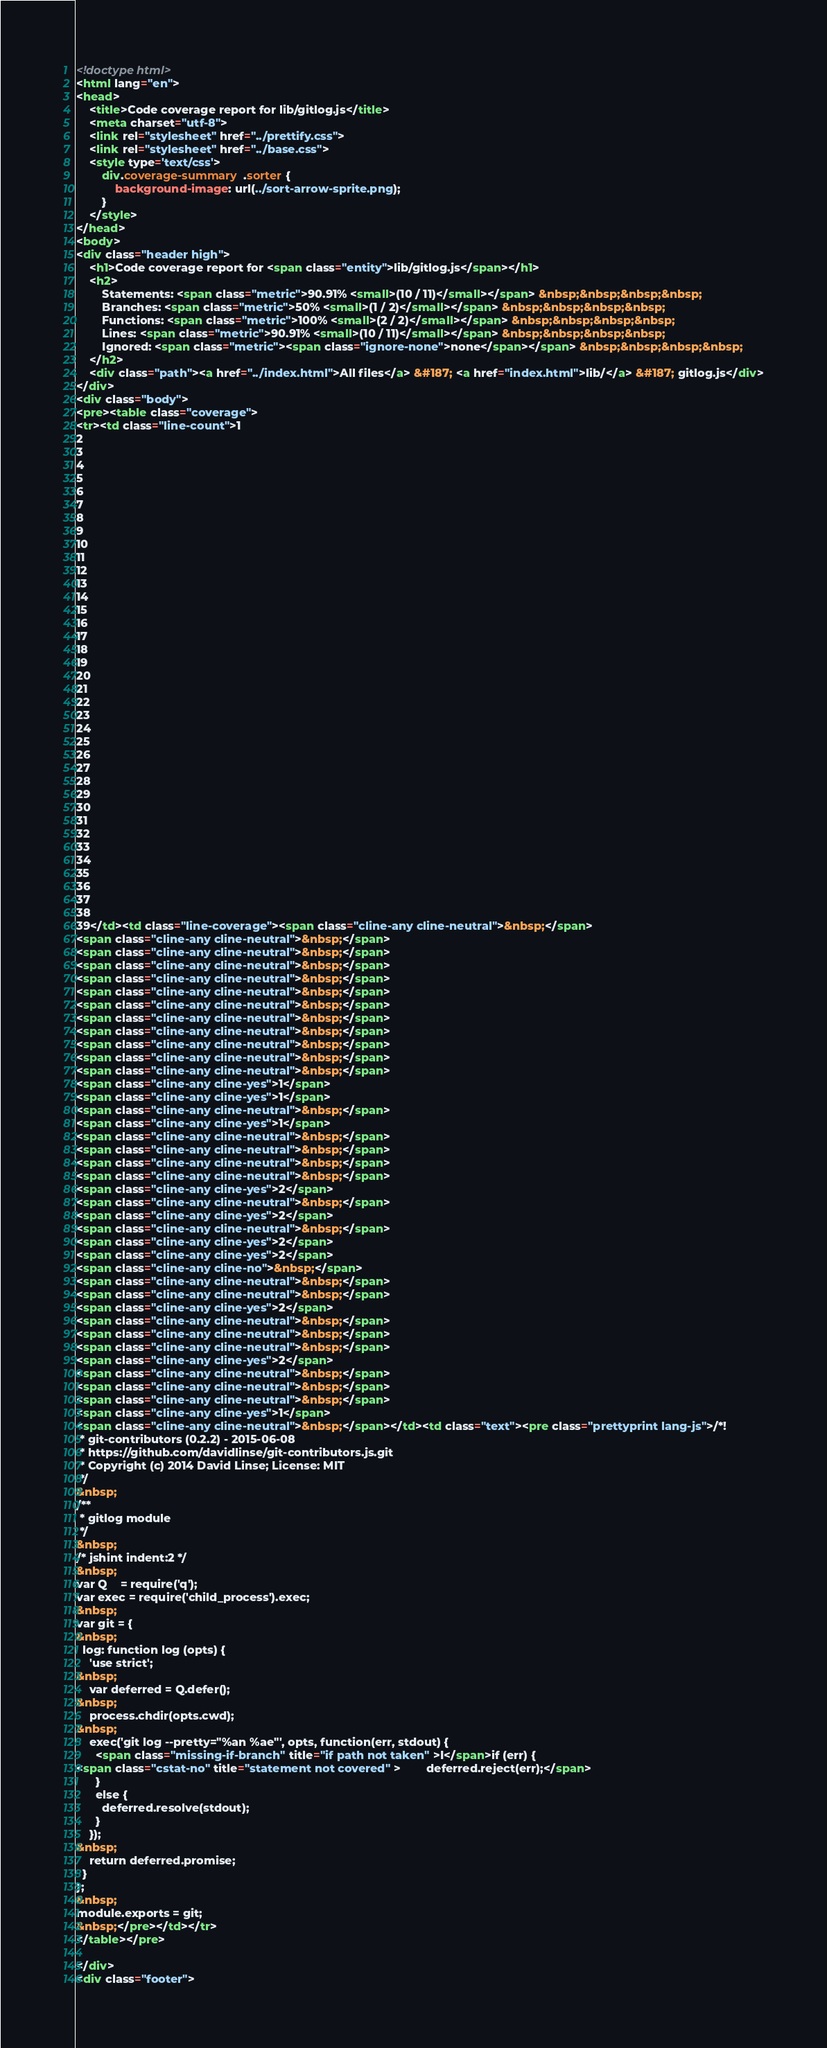<code> <loc_0><loc_0><loc_500><loc_500><_HTML_><!doctype html>
<html lang="en">
<head>
    <title>Code coverage report for lib/gitlog.js</title>
    <meta charset="utf-8">
    <link rel="stylesheet" href="../prettify.css">
    <link rel="stylesheet" href="../base.css">
    <style type='text/css'>
        div.coverage-summary .sorter {
            background-image: url(../sort-arrow-sprite.png);
        }
    </style>
</head>
<body>
<div class="header high">
    <h1>Code coverage report for <span class="entity">lib/gitlog.js</span></h1>
    <h2>
        Statements: <span class="metric">90.91% <small>(10 / 11)</small></span> &nbsp;&nbsp;&nbsp;&nbsp;
        Branches: <span class="metric">50% <small>(1 / 2)</small></span> &nbsp;&nbsp;&nbsp;&nbsp;
        Functions: <span class="metric">100% <small>(2 / 2)</small></span> &nbsp;&nbsp;&nbsp;&nbsp;
        Lines: <span class="metric">90.91% <small>(10 / 11)</small></span> &nbsp;&nbsp;&nbsp;&nbsp;
        Ignored: <span class="metric"><span class="ignore-none">none</span></span> &nbsp;&nbsp;&nbsp;&nbsp;
    </h2>
    <div class="path"><a href="../index.html">All files</a> &#187; <a href="index.html">lib/</a> &#187; gitlog.js</div>
</div>
<div class="body">
<pre><table class="coverage">
<tr><td class="line-count">1
2
3
4
5
6
7
8
9
10
11
12
13
14
15
16
17
18
19
20
21
22
23
24
25
26
27
28
29
30
31
32
33
34
35
36
37
38
39</td><td class="line-coverage"><span class="cline-any cline-neutral">&nbsp;</span>
<span class="cline-any cline-neutral">&nbsp;</span>
<span class="cline-any cline-neutral">&nbsp;</span>
<span class="cline-any cline-neutral">&nbsp;</span>
<span class="cline-any cline-neutral">&nbsp;</span>
<span class="cline-any cline-neutral">&nbsp;</span>
<span class="cline-any cline-neutral">&nbsp;</span>
<span class="cline-any cline-neutral">&nbsp;</span>
<span class="cline-any cline-neutral">&nbsp;</span>
<span class="cline-any cline-neutral">&nbsp;</span>
<span class="cline-any cline-neutral">&nbsp;</span>
<span class="cline-any cline-neutral">&nbsp;</span>
<span class="cline-any cline-yes">1</span>
<span class="cline-any cline-yes">1</span>
<span class="cline-any cline-neutral">&nbsp;</span>
<span class="cline-any cline-yes">1</span>
<span class="cline-any cline-neutral">&nbsp;</span>
<span class="cline-any cline-neutral">&nbsp;</span>
<span class="cline-any cline-neutral">&nbsp;</span>
<span class="cline-any cline-neutral">&nbsp;</span>
<span class="cline-any cline-yes">2</span>
<span class="cline-any cline-neutral">&nbsp;</span>
<span class="cline-any cline-yes">2</span>
<span class="cline-any cline-neutral">&nbsp;</span>
<span class="cline-any cline-yes">2</span>
<span class="cline-any cline-yes">2</span>
<span class="cline-any cline-no">&nbsp;</span>
<span class="cline-any cline-neutral">&nbsp;</span>
<span class="cline-any cline-neutral">&nbsp;</span>
<span class="cline-any cline-yes">2</span>
<span class="cline-any cline-neutral">&nbsp;</span>
<span class="cline-any cline-neutral">&nbsp;</span>
<span class="cline-any cline-neutral">&nbsp;</span>
<span class="cline-any cline-yes">2</span>
<span class="cline-any cline-neutral">&nbsp;</span>
<span class="cline-any cline-neutral">&nbsp;</span>
<span class="cline-any cline-neutral">&nbsp;</span>
<span class="cline-any cline-yes">1</span>
<span class="cline-any cline-neutral">&nbsp;</span></td><td class="text"><pre class="prettyprint lang-js">/*!
 * git-contributors (0.2.2) - 2015-06-08
 * https://github.com/davidlinse/git-contributors.js.git
 * Copyright (c) 2014 David Linse; License: MIT
 */
&nbsp;
/**
 * gitlog module
 */
&nbsp;
/* jshint indent:2 */
&nbsp;
var Q    = require('q');
var exec = require('child_process').exec;
&nbsp;
var git = {
&nbsp;
  log: function log (opts) {
    'use strict';
&nbsp;
    var deferred = Q.defer();
&nbsp;
    process.chdir(opts.cwd);
&nbsp;
    exec('git log --pretty="%an %ae"', opts, function(err, stdout) {
      <span class="missing-if-branch" title="if path not taken" >I</span>if (err) {
<span class="cstat-no" title="statement not covered" >        deferred.reject(err);</span>
      }
      else {
        deferred.resolve(stdout);
      }
    });
&nbsp;
    return deferred.promise;
  }
};
&nbsp;
module.exports = git;
&nbsp;</pre></td></tr>
</table></pre>

</div>
<div class="footer"></code> 